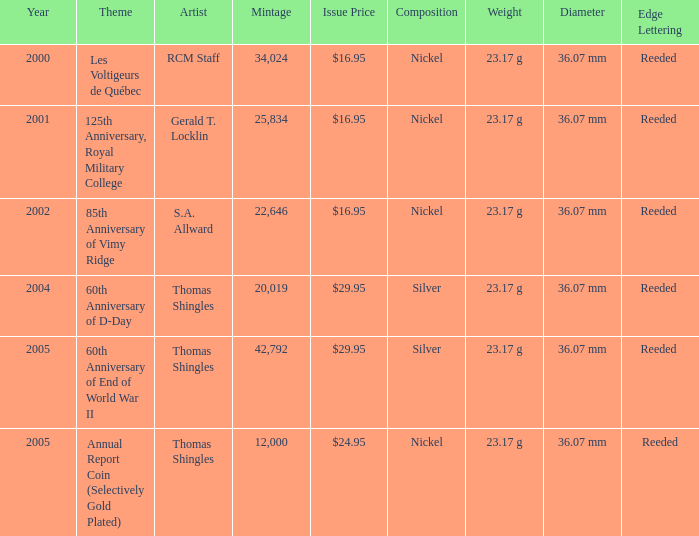What was the total mintage for years after 2002 that had a 85th Anniversary of Vimy Ridge theme? 0.0. 